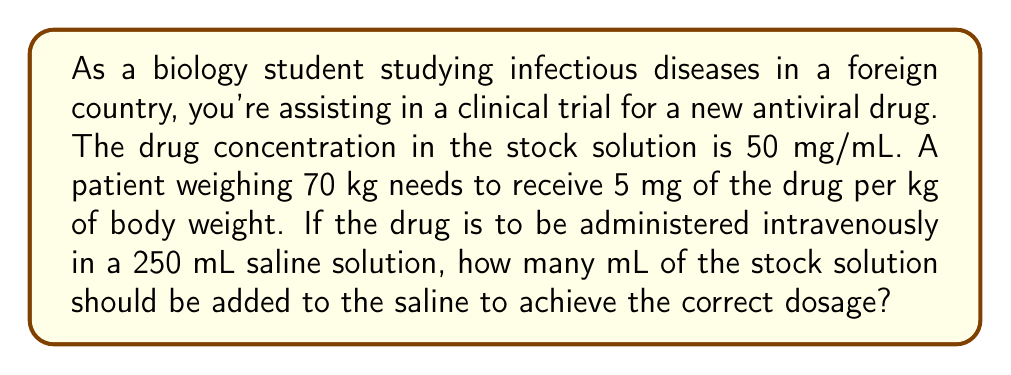Show me your answer to this math problem. Let's approach this problem step-by-step:

1. Calculate the total drug dosage needed:
   $$\text{Total dose} = \text{Patient weight} \times \text{Dose per kg}$$
   $$\text{Total dose} = 70 \text{ kg} \times 5 \text{ mg/kg} = 350 \text{ mg}$$

2. Set up a proportion to find the volume of stock solution needed:
   $$\frac{\text{Concentration of stock}}{\text{Volume of stock}} = \frac{\text{Total dose}}{\text{Volume of stock}}$$

   $$\frac{50 \text{ mg/mL}}{x \text{ mL}} = \frac{350 \text{ mg}}{x \text{ mL}}$$

3. Cross multiply:
   $$50x = 350$$

4. Solve for x:
   $$x = \frac{350}{50} = 7 \text{ mL}$$

Therefore, 7 mL of the stock solution should be added to the 250 mL saline solution to achieve the correct dosage for the patient.
Answer: 7 mL 